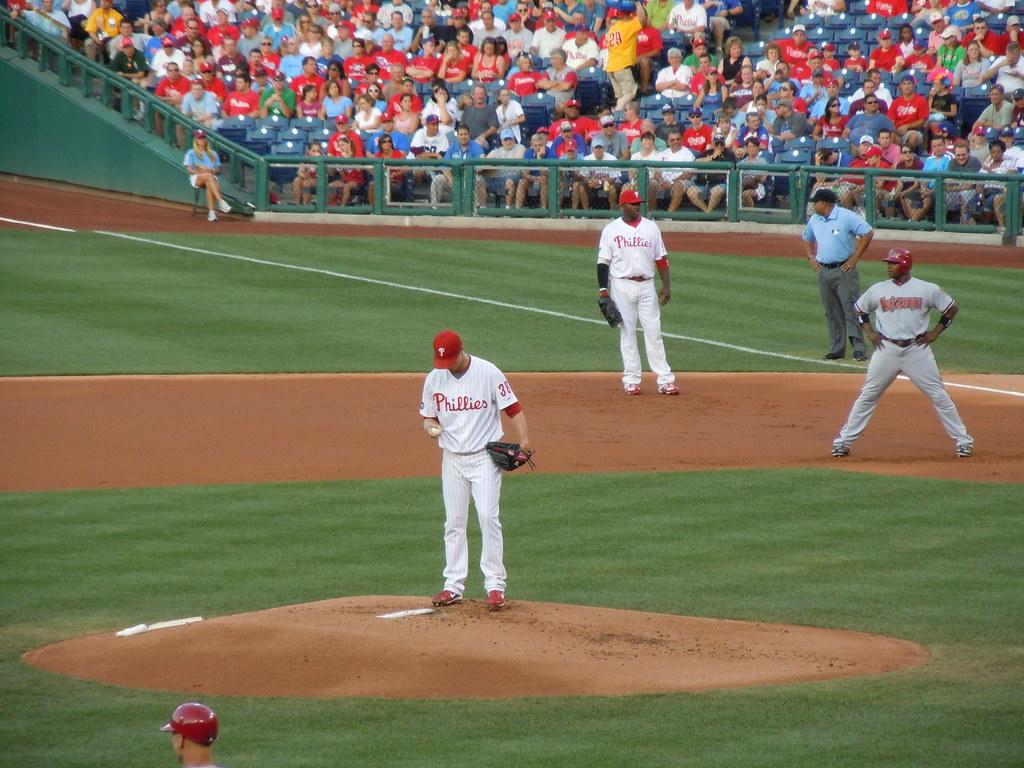What team is the pitcher from?
Offer a very short reply. Phillies. 